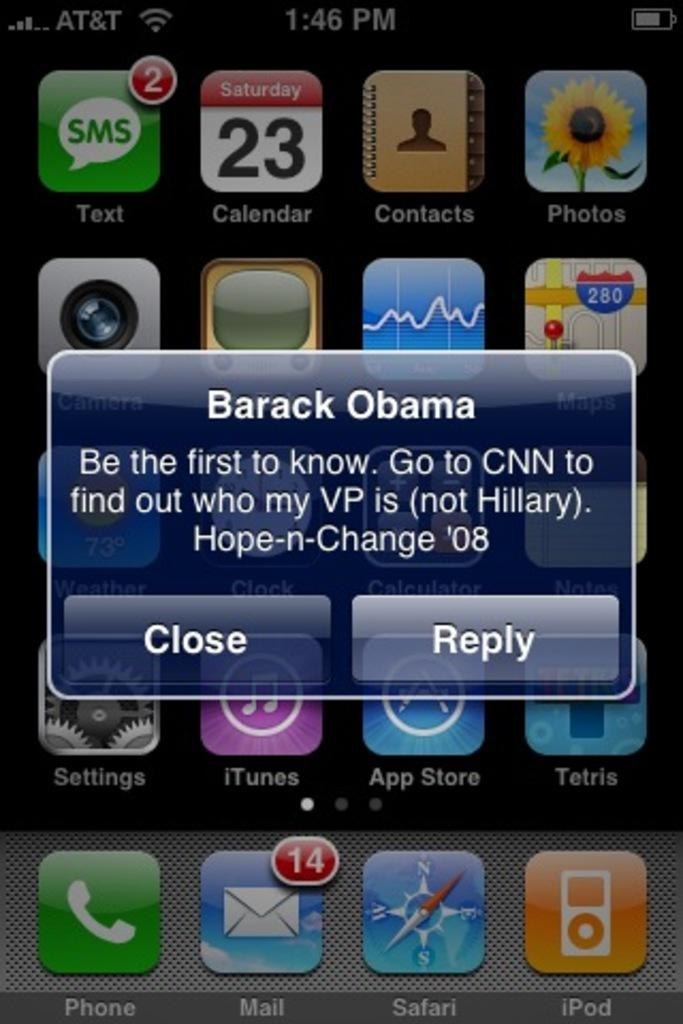What is the main subject of the image? The main subject of the image is a screen. What can be seen on the screen? There are icons and a popup message on the screen. How many potatoes are visible on the screen in the image? There are no potatoes visible on the screen in the image. What type of star can be seen in the image? There is no star present in the image; it is a screen with icons and a popup message. 